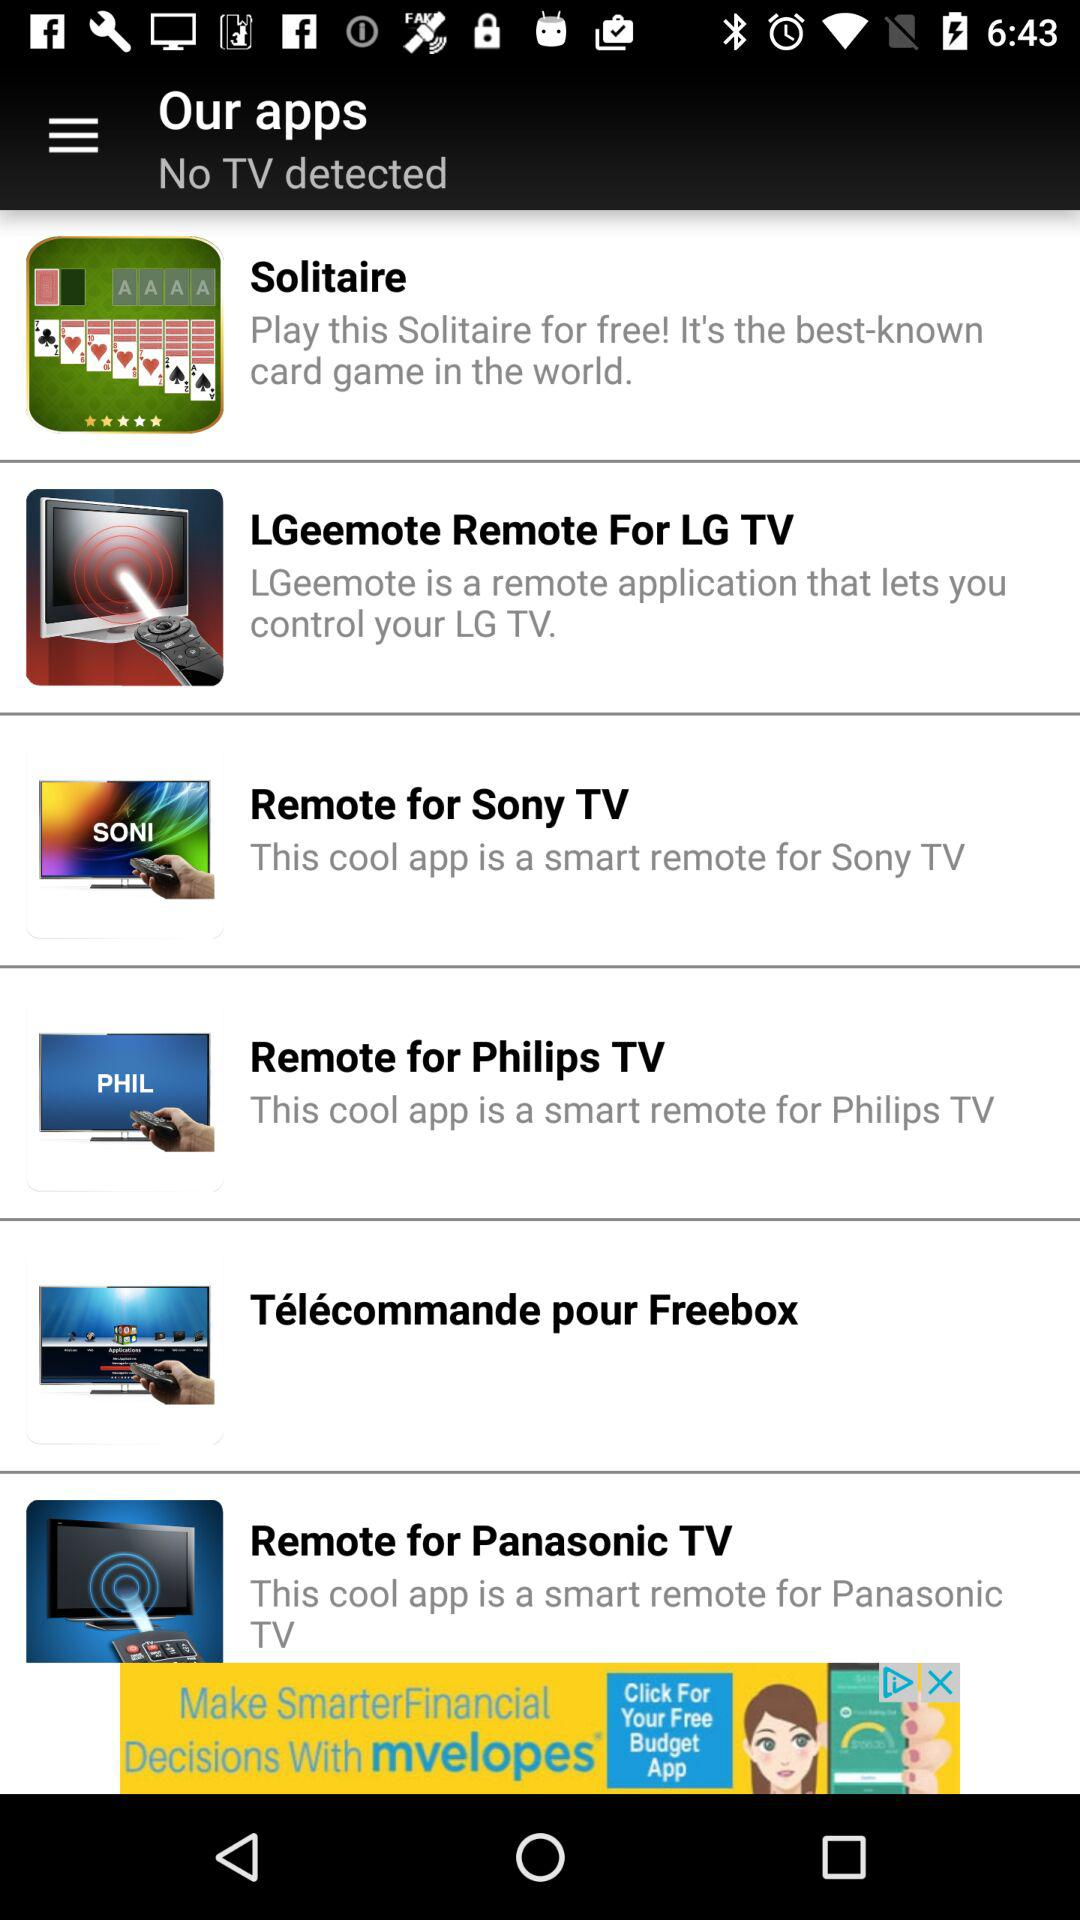How many apps are there for TVs?
Answer the question using a single word or phrase. 5 